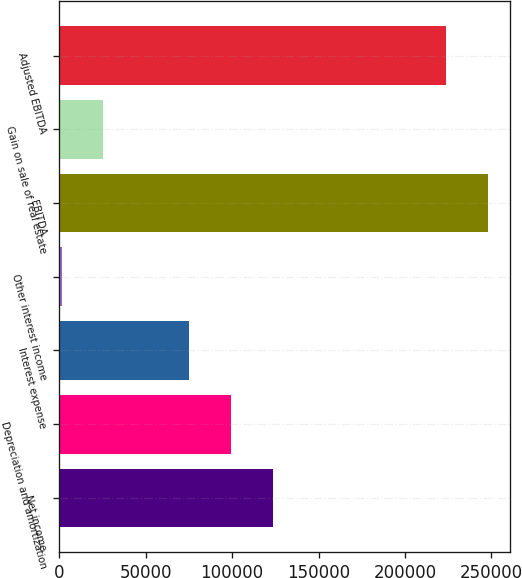Convert chart. <chart><loc_0><loc_0><loc_500><loc_500><bar_chart><fcel>Net income<fcel>Depreciation and amortization<fcel>Interest expense<fcel>Other interest income<fcel>EBITDA<fcel>Gain on sale of real estate<fcel>Adjusted EBITDA<nl><fcel>123768<fcel>99500<fcel>75232<fcel>1276<fcel>248171<fcel>25544<fcel>223903<nl></chart> 